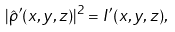Convert formula to latex. <formula><loc_0><loc_0><loc_500><loc_500>| \hat { \rho } ^ { \prime } ( x , y , z ) | ^ { 2 } = I ^ { \prime } ( x , y , z ) ,</formula> 